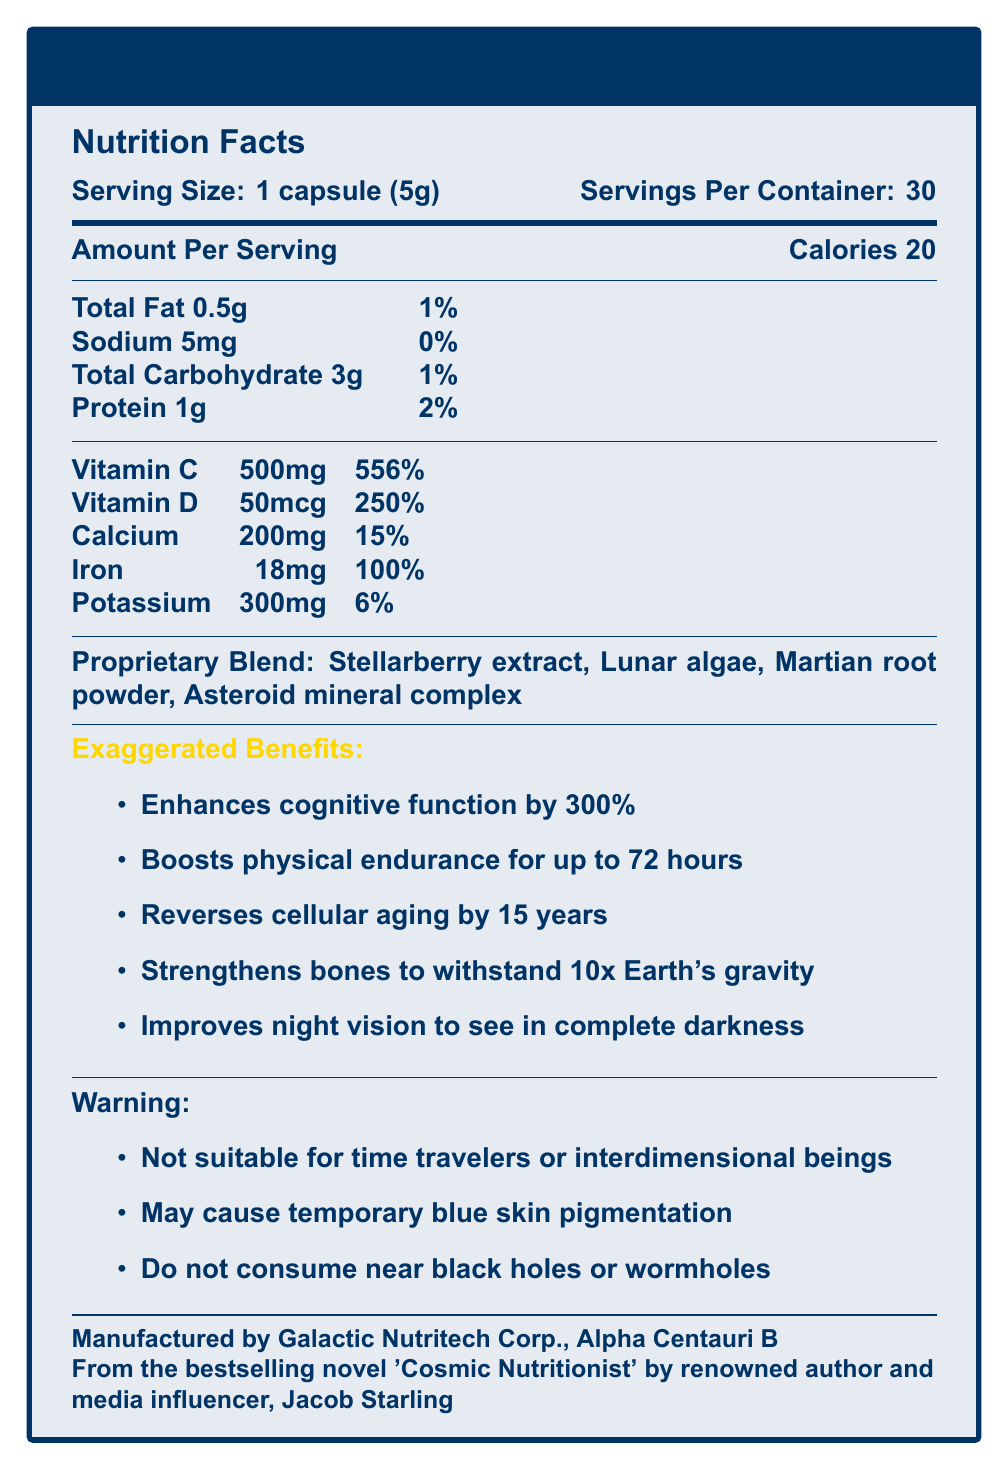what is the serving size? The serving size is stated at the beginning of the nutrition facts section as "Serving Size: 1 capsule (5g)".
Answer: 1 capsule (5g) how many servings are there per container? The document specifies "Servings Per Container: 30" near the serving size information.
Answer: 30 how many calories are there per serving? The document lists the calories per serving under "Amount Per Serving" as 20.
Answer: 20 what percentage of the daily value of Vitamin C does one serving provide? The document lists the daily value percentage of Vitamin C as 556%.
Answer: 556% what are the ingredients in the proprietary blend? The document lists these ingredients under "Proprietary Blend".
Answer: Stellarberry extract, Lunar algae, Martian root powder, Asteroid mineral complex which vitamin has the highest daily value percentage in one serving? A. Vitamin C B. Vitamin D C. Calcium D. Iron Vitamin C provides 556% of the daily value, which is the highest percentage compared to other vitamins listed.
Answer: A. Vitamin C how long does the boosted physical endurance last according to the exaggerated benefits? A. 24 hours B. 48 hours C. 72 hours D. 96 hours One of the exaggerated benefits listed is "Boosts physical endurance for up to 72 hours".
Answer: C. 72 hours is Stellarberry Elixir suitable for time travelers? One of the warnings explicitly states "Not suitable for time travelers or interdimensional beings".
Answer: No summarize the document. The nutrition facts section presents detailed nutrient information, the exaggerated benefits section lists remarkable claims, and the warnings provide usage cautions. Additional information about the manufacturer and the novel reference is also included.
Answer: The document provides the nutrition facts for Stellarberry Elixir, a fictional superfood capsule featured in a sci-fi novel. It includes the serving size, calories, and nutrient information. Also listed are exaggerated health benefits, warnings, the manufacturer, and a reference to the novel. what is the amount of protein per serving? The document lists protein content under "Amount Per Serving" as 1g.
Answer: 1g what colors are used in the nutrition facts label design? The document mentions "spaceblue" and "starlightgold" colors in the LaTeX setup code.
Answer: Space blue and starlight gold does the document mention any side effects of Stellarberry Elixir? The document mentions side effects in the warnings, such as "May cause temporary blue skin pigmentation".
Answer: Yes who is the author of the novel referenced in the document? The document references the novel "Cosmic Nutritionist" by Jacob Starling.
Answer: Jacob Starling where is the manufacturer located? The document states the manufacturer as "Galactic Nutritech Corp., Alpha Centauri B".
Answer: Alpha Centauri B what types of minerals are in the proprietary blend? The document lists the components of the proprietary blend but doesn't specify the types of minerals in the "Asteroid mineral complex".
Answer: Cannot be determined 